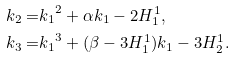Convert formula to latex. <formula><loc_0><loc_0><loc_500><loc_500>k _ { 2 } = & { k _ { 1 } } ^ { 2 } + \alpha k _ { 1 } - 2 H ^ { 1 } _ { 1 } , \\ k _ { 3 } = & { k _ { 1 } } ^ { 3 } + ( \beta - 3 H ^ { 1 } _ { 1 } ) k _ { 1 } - 3 H ^ { 1 } _ { 2 } .</formula> 